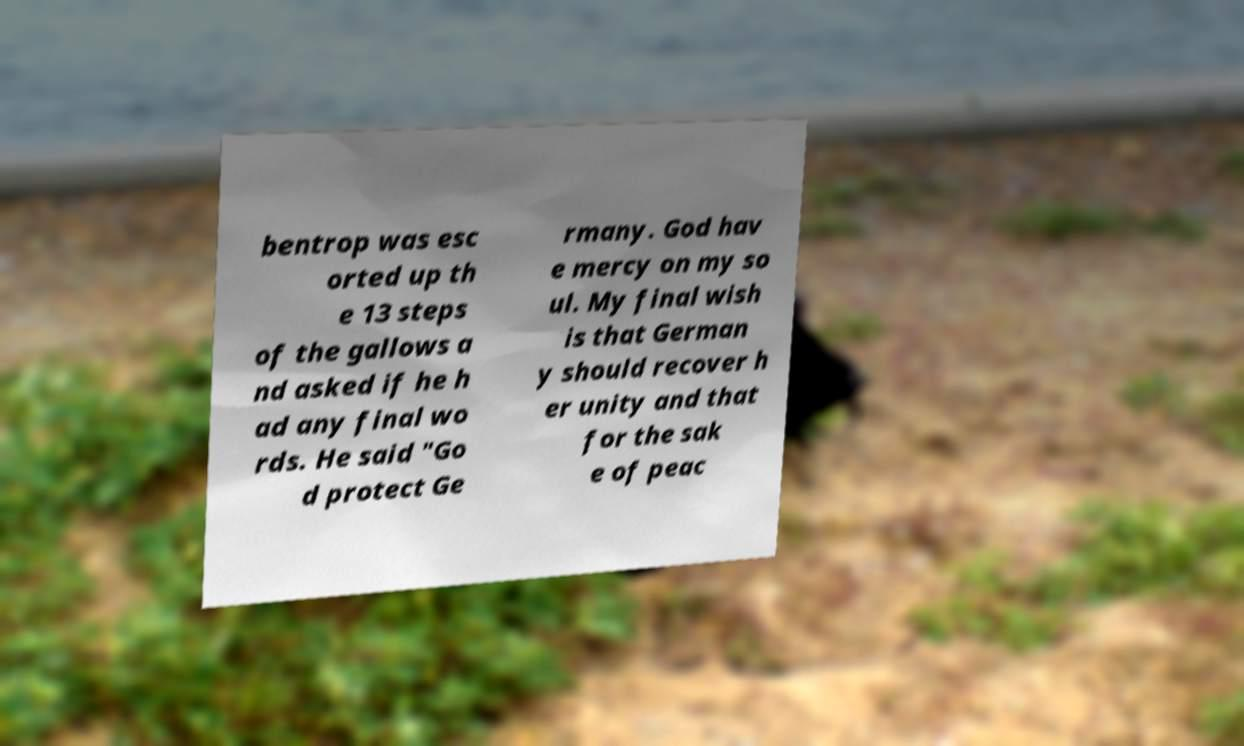Could you extract and type out the text from this image? bentrop was esc orted up th e 13 steps of the gallows a nd asked if he h ad any final wo rds. He said "Go d protect Ge rmany. God hav e mercy on my so ul. My final wish is that German y should recover h er unity and that for the sak e of peac 